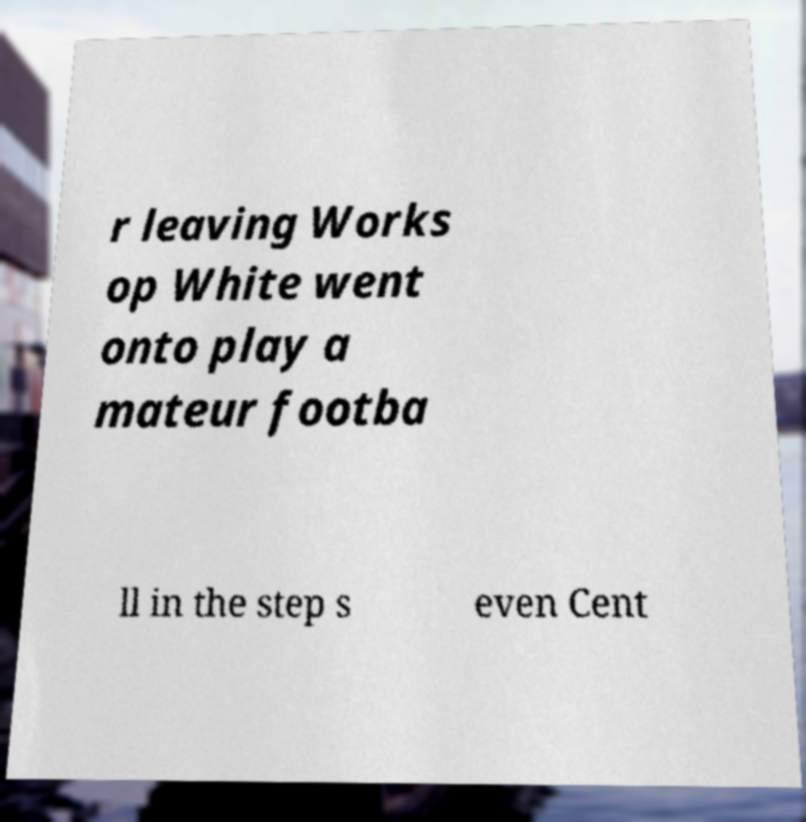Could you extract and type out the text from this image? r leaving Works op White went onto play a mateur footba ll in the step s even Cent 